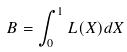<formula> <loc_0><loc_0><loc_500><loc_500>B = \int _ { 0 } ^ { 1 } L ( X ) d X</formula> 